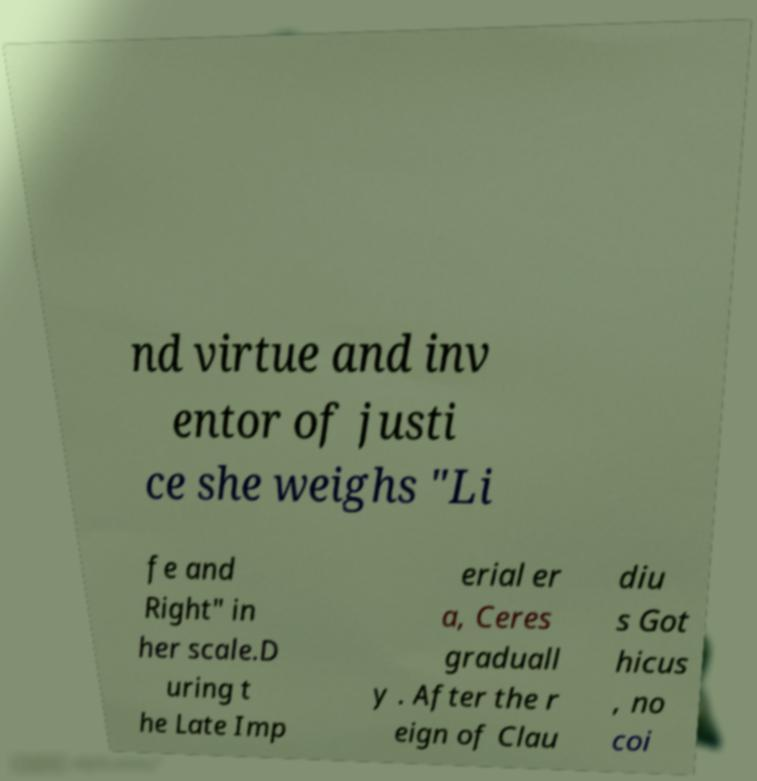Can you accurately transcribe the text from the provided image for me? nd virtue and inv entor of justi ce she weighs "Li fe and Right" in her scale.D uring t he Late Imp erial er a, Ceres graduall y . After the r eign of Clau diu s Got hicus , no coi 